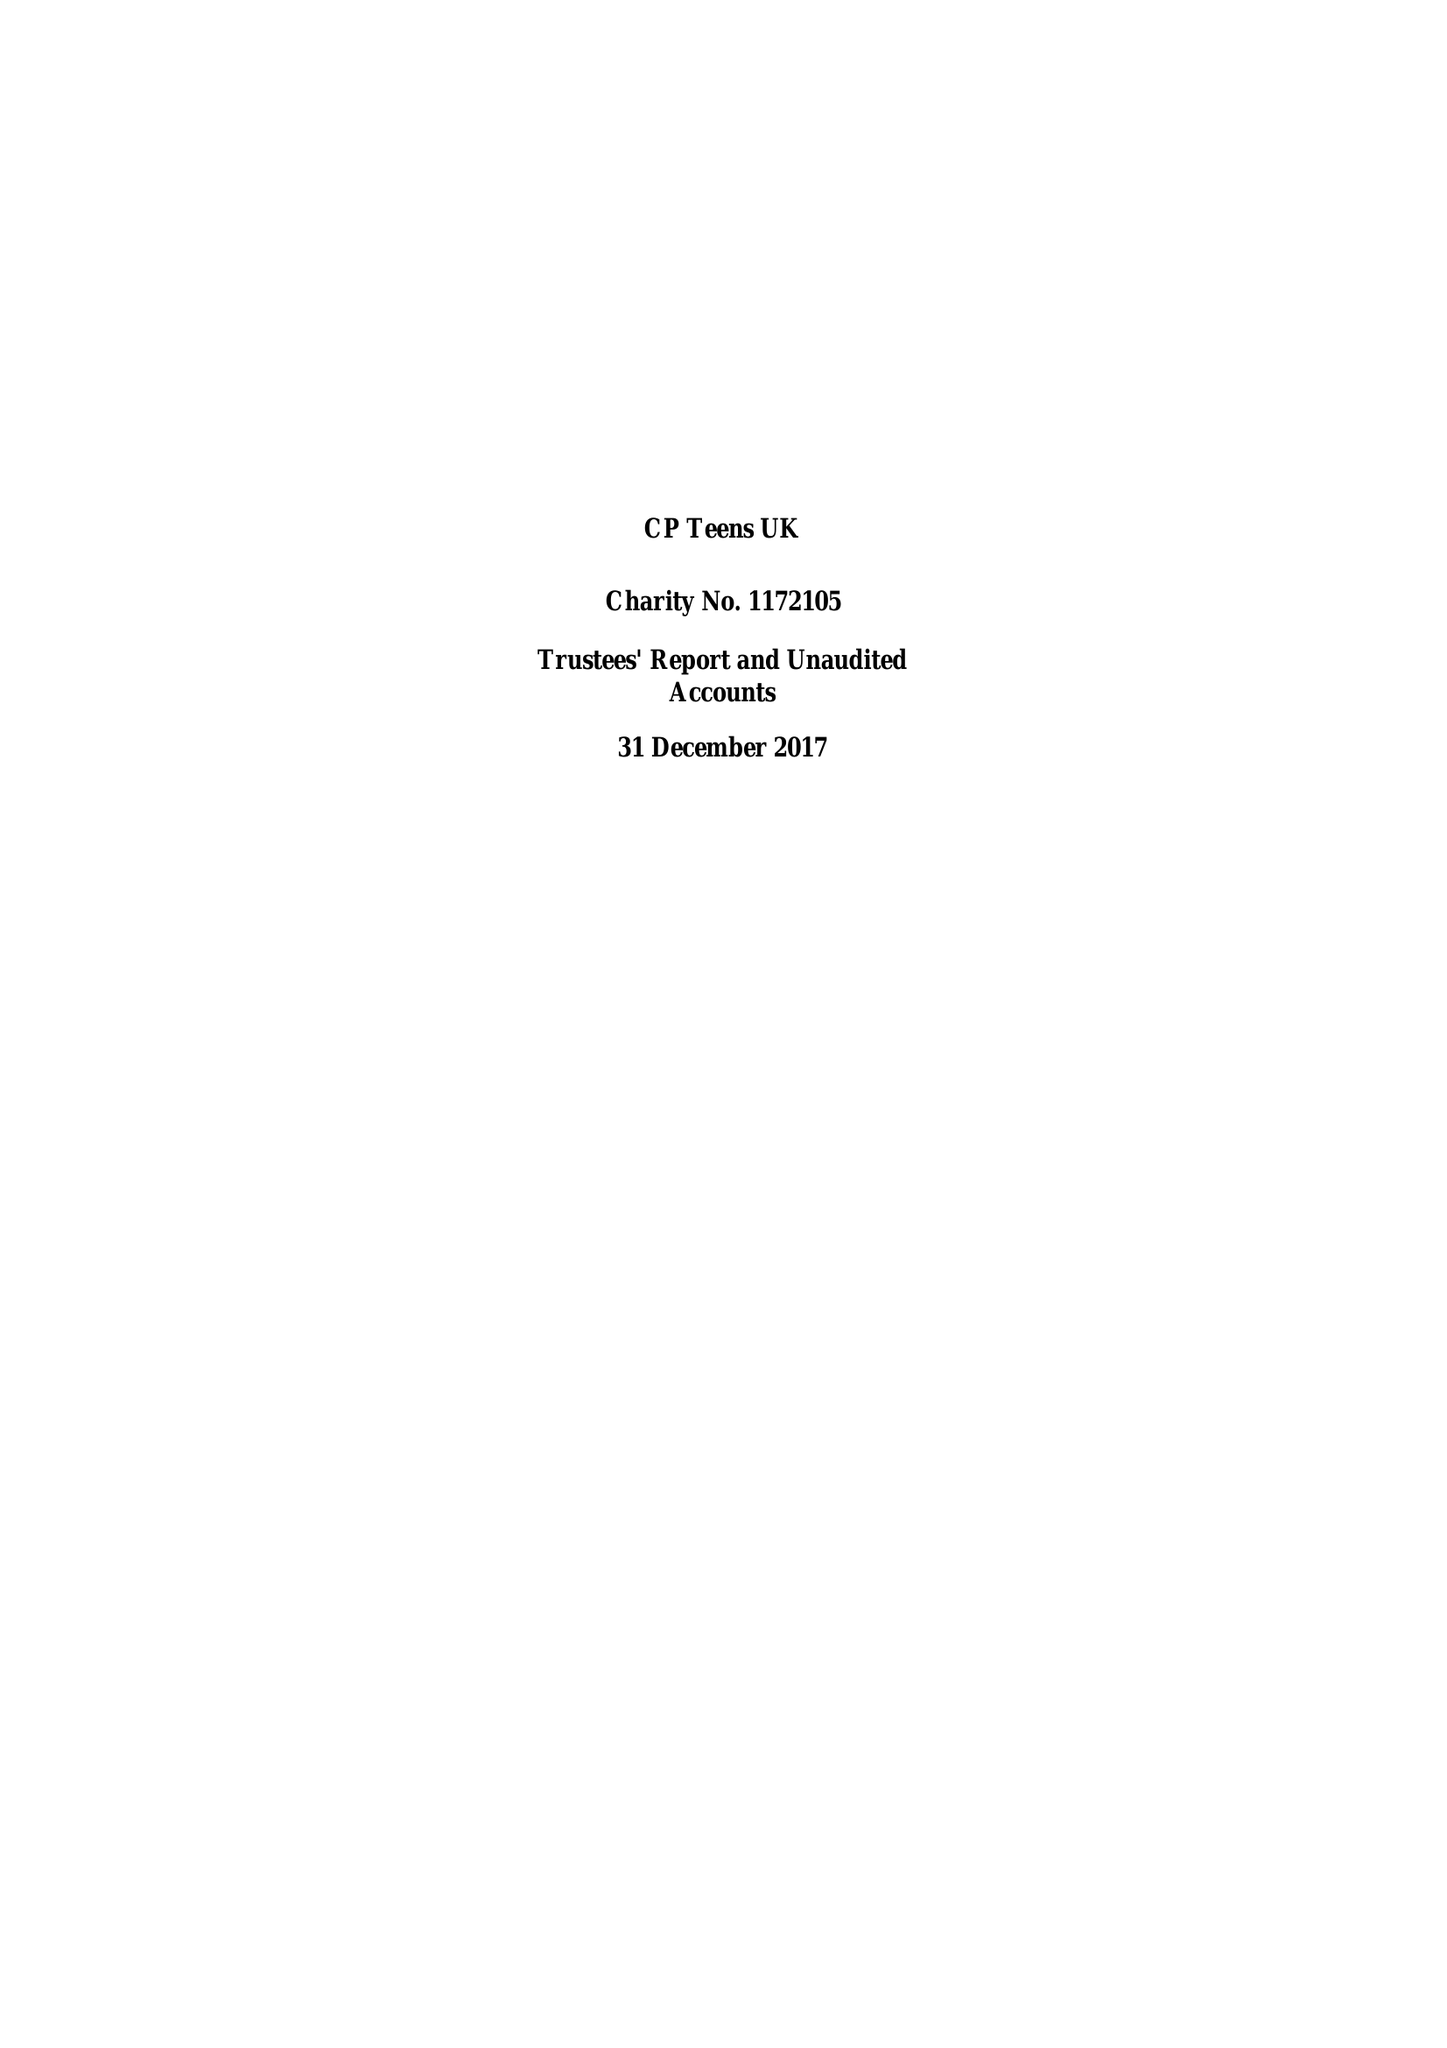What is the value for the income_annually_in_british_pounds?
Answer the question using a single word or phrase. 18550.00 